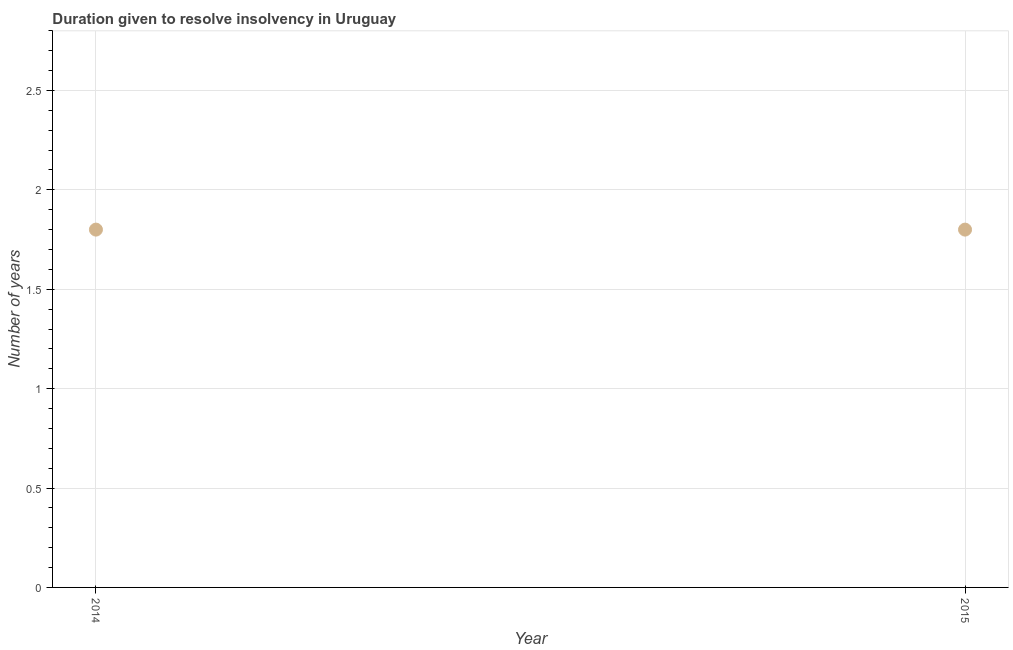What is the number of years to resolve insolvency in 2015?
Provide a succinct answer. 1.8. Across all years, what is the maximum number of years to resolve insolvency?
Your answer should be compact. 1.8. In which year was the number of years to resolve insolvency maximum?
Offer a terse response. 2014. In which year was the number of years to resolve insolvency minimum?
Provide a succinct answer. 2014. What is the sum of the number of years to resolve insolvency?
Ensure brevity in your answer.  3.6. What is the difference between the number of years to resolve insolvency in 2014 and 2015?
Offer a terse response. 0. What is the median number of years to resolve insolvency?
Offer a terse response. 1.8. In how many years, is the number of years to resolve insolvency greater than the average number of years to resolve insolvency taken over all years?
Provide a succinct answer. 0. Does the number of years to resolve insolvency monotonically increase over the years?
Offer a terse response. No. Are the values on the major ticks of Y-axis written in scientific E-notation?
Give a very brief answer. No. What is the title of the graph?
Ensure brevity in your answer.  Duration given to resolve insolvency in Uruguay. What is the label or title of the X-axis?
Keep it short and to the point. Year. What is the label or title of the Y-axis?
Your response must be concise. Number of years. What is the Number of years in 2014?
Provide a succinct answer. 1.8. What is the ratio of the Number of years in 2014 to that in 2015?
Provide a short and direct response. 1. 